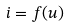<formula> <loc_0><loc_0><loc_500><loc_500>i = f ( u )</formula> 